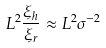<formula> <loc_0><loc_0><loc_500><loc_500>L ^ { 2 } \frac { \xi _ { h } } { \xi _ { r } } \approx L ^ { 2 } \sigma ^ { - 2 }</formula> 